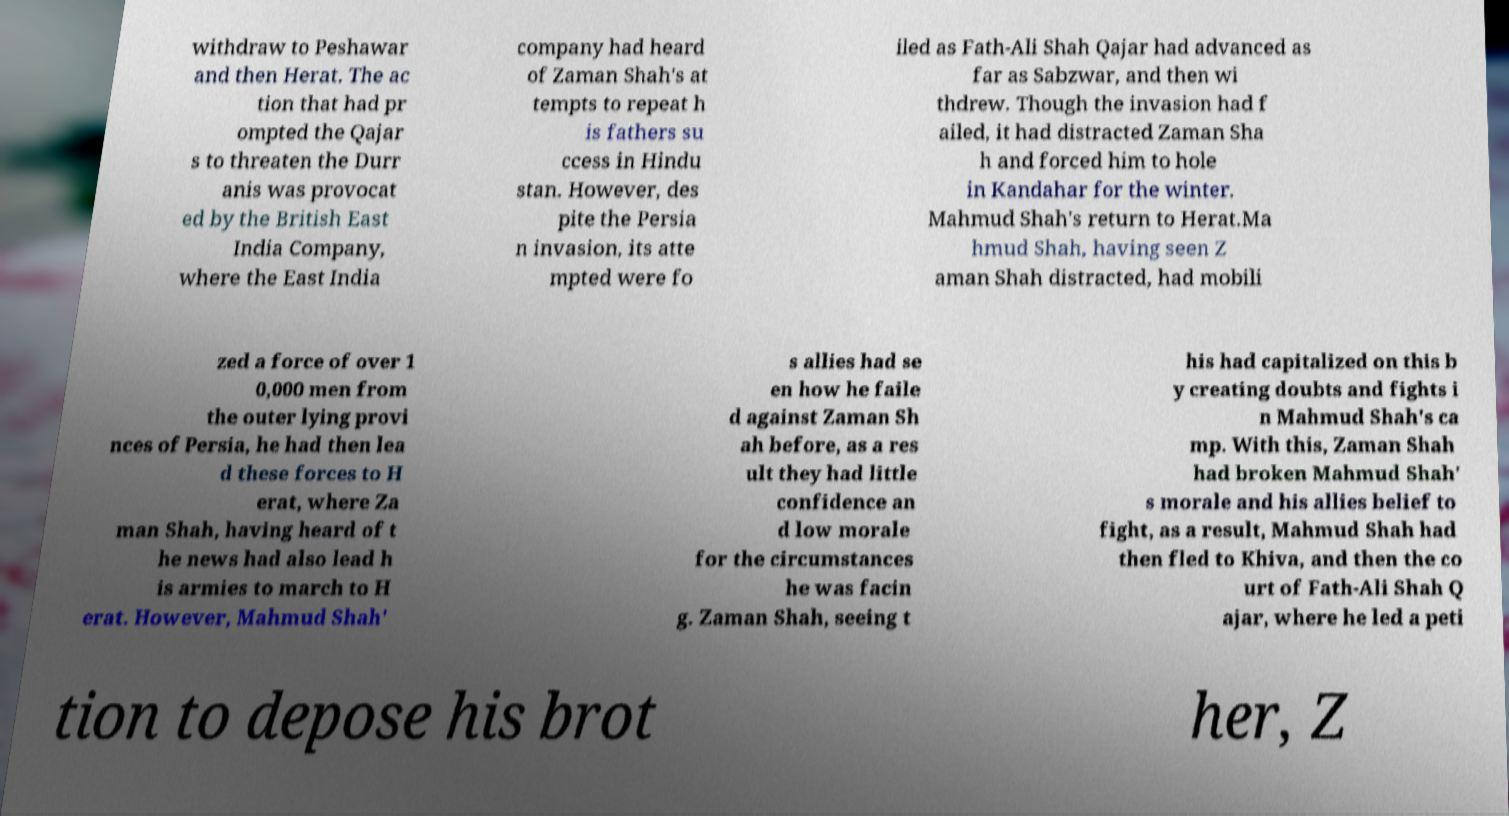Can you accurately transcribe the text from the provided image for me? withdraw to Peshawar and then Herat. The ac tion that had pr ompted the Qajar s to threaten the Durr anis was provocat ed by the British East India Company, where the East India company had heard of Zaman Shah's at tempts to repeat h is fathers su ccess in Hindu stan. However, des pite the Persia n invasion, its atte mpted were fo iled as Fath-Ali Shah Qajar had advanced as far as Sabzwar, and then wi thdrew. Though the invasion had f ailed, it had distracted Zaman Sha h and forced him to hole in Kandahar for the winter. Mahmud Shah's return to Herat.Ma hmud Shah, having seen Z aman Shah distracted, had mobili zed a force of over 1 0,000 men from the outer lying provi nces of Persia, he had then lea d these forces to H erat, where Za man Shah, having heard of t he news had also lead h is armies to march to H erat. However, Mahmud Shah' s allies had se en how he faile d against Zaman Sh ah before, as a res ult they had little confidence an d low morale for the circumstances he was facin g. Zaman Shah, seeing t his had capitalized on this b y creating doubts and fights i n Mahmud Shah's ca mp. With this, Zaman Shah had broken Mahmud Shah' s morale and his allies belief to fight, as a result, Mahmud Shah had then fled to Khiva, and then the co urt of Fath-Ali Shah Q ajar, where he led a peti tion to depose his brot her, Z 